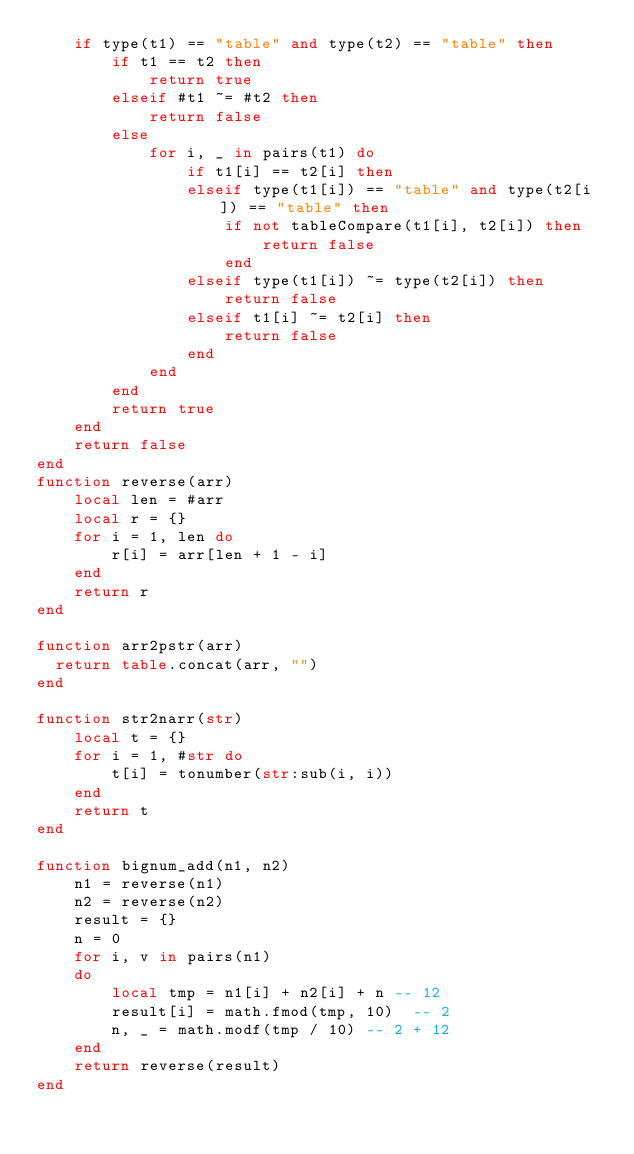Convert code to text. <code><loc_0><loc_0><loc_500><loc_500><_Lua_>    if type(t1) == "table" and type(t2) == "table" then
        if t1 == t2 then
            return true
        elseif #t1 ~= #t2 then
            return false
        else
            for i, _ in pairs(t1) do
                if t1[i] == t2[i] then
                elseif type(t1[i]) == "table" and type(t2[i]) == "table" then 
                    if not tableCompare(t1[i], t2[i]) then
                        return false
                    end
                elseif type(t1[i]) ~= type(t2[i]) then
                    return false
                elseif t1[i] ~= t2[i] then
                    return false
                end
            end
        end
        return true
    end
    return false
end
function reverse(arr)
    local len = #arr
    local r = {}
    for i = 1, len do
        r[i] = arr[len + 1 - i]
    end
    return r
end

function arr2pstr(arr)
  return table.concat(arr, "")
end

function str2narr(str)
    local t = {}
    for i = 1, #str do
        t[i] = tonumber(str:sub(i, i))
    end
    return t
end

function bignum_add(n1, n2)
    n1 = reverse(n1)
    n2 = reverse(n2)
    result = {}
    n = 0
    for i, v in pairs(n1)
    do
        local tmp = n1[i] + n2[i] + n -- 12
        result[i] = math.fmod(tmp, 10)  -- 2
        n, _ = math.modf(tmp / 10) -- 2 + 12
    end
    return reverse(result)
end
</code> 